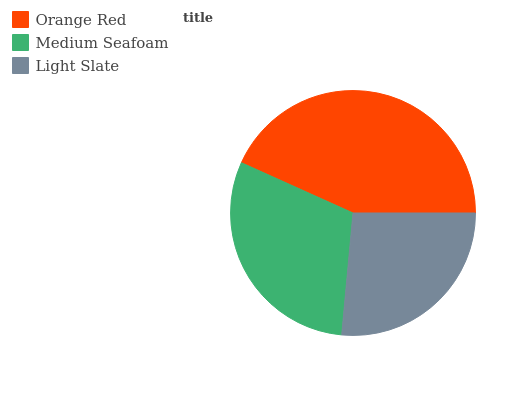Is Light Slate the minimum?
Answer yes or no. Yes. Is Orange Red the maximum?
Answer yes or no. Yes. Is Medium Seafoam the minimum?
Answer yes or no. No. Is Medium Seafoam the maximum?
Answer yes or no. No. Is Orange Red greater than Medium Seafoam?
Answer yes or no. Yes. Is Medium Seafoam less than Orange Red?
Answer yes or no. Yes. Is Medium Seafoam greater than Orange Red?
Answer yes or no. No. Is Orange Red less than Medium Seafoam?
Answer yes or no. No. Is Medium Seafoam the high median?
Answer yes or no. Yes. Is Medium Seafoam the low median?
Answer yes or no. Yes. Is Orange Red the high median?
Answer yes or no. No. Is Orange Red the low median?
Answer yes or no. No. 